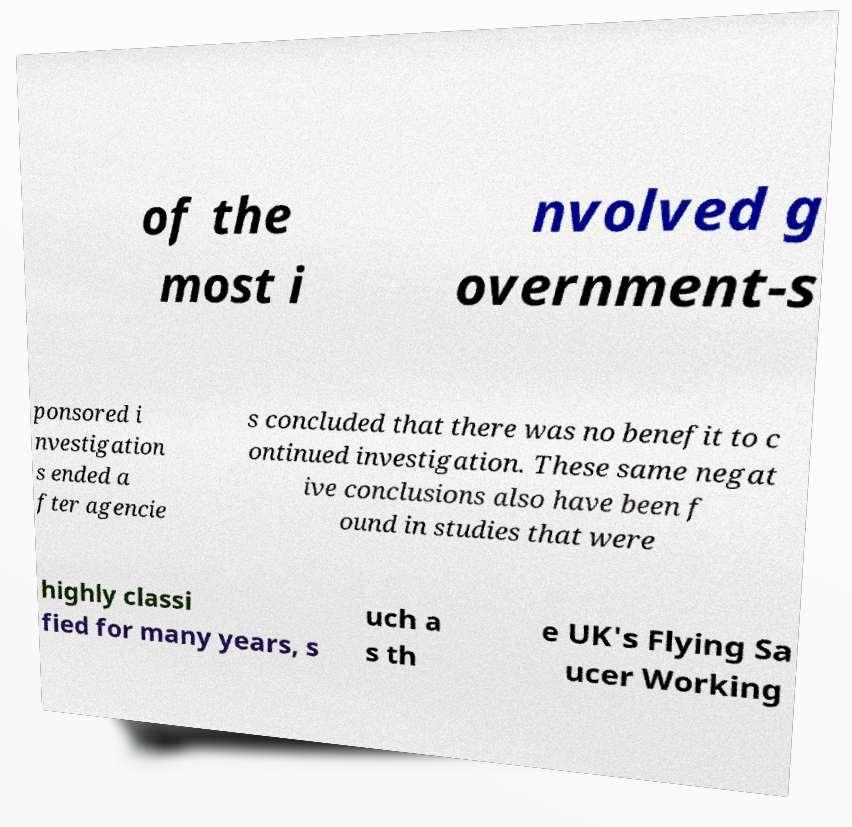There's text embedded in this image that I need extracted. Can you transcribe it verbatim? of the most i nvolved g overnment-s ponsored i nvestigation s ended a fter agencie s concluded that there was no benefit to c ontinued investigation. These same negat ive conclusions also have been f ound in studies that were highly classi fied for many years, s uch a s th e UK's Flying Sa ucer Working 